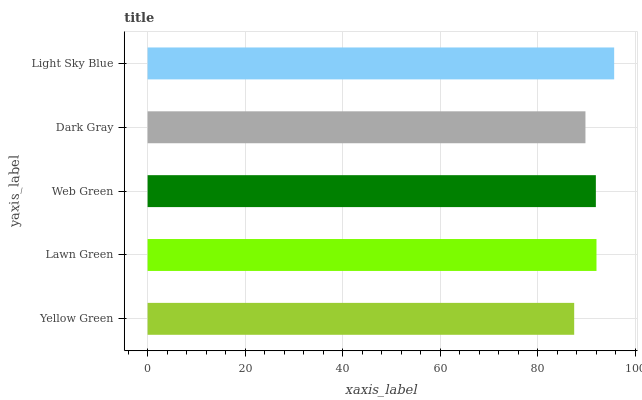Is Yellow Green the minimum?
Answer yes or no. Yes. Is Light Sky Blue the maximum?
Answer yes or no. Yes. Is Lawn Green the minimum?
Answer yes or no. No. Is Lawn Green the maximum?
Answer yes or no. No. Is Lawn Green greater than Yellow Green?
Answer yes or no. Yes. Is Yellow Green less than Lawn Green?
Answer yes or no. Yes. Is Yellow Green greater than Lawn Green?
Answer yes or no. No. Is Lawn Green less than Yellow Green?
Answer yes or no. No. Is Web Green the high median?
Answer yes or no. Yes. Is Web Green the low median?
Answer yes or no. Yes. Is Lawn Green the high median?
Answer yes or no. No. Is Light Sky Blue the low median?
Answer yes or no. No. 